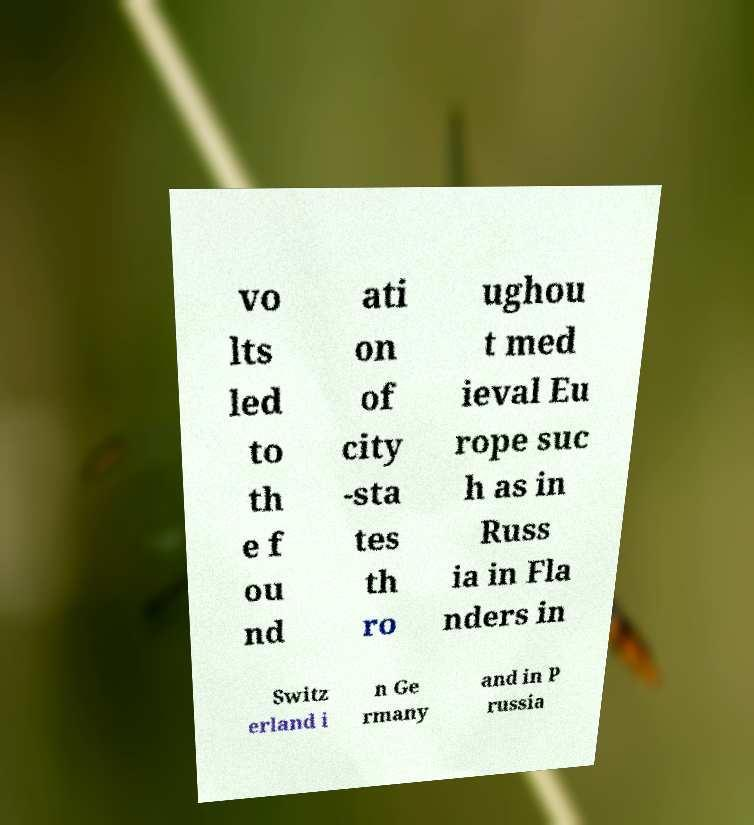There's text embedded in this image that I need extracted. Can you transcribe it verbatim? vo lts led to th e f ou nd ati on of city -sta tes th ro ughou t med ieval Eu rope suc h as in Russ ia in Fla nders in Switz erland i n Ge rmany and in P russia 